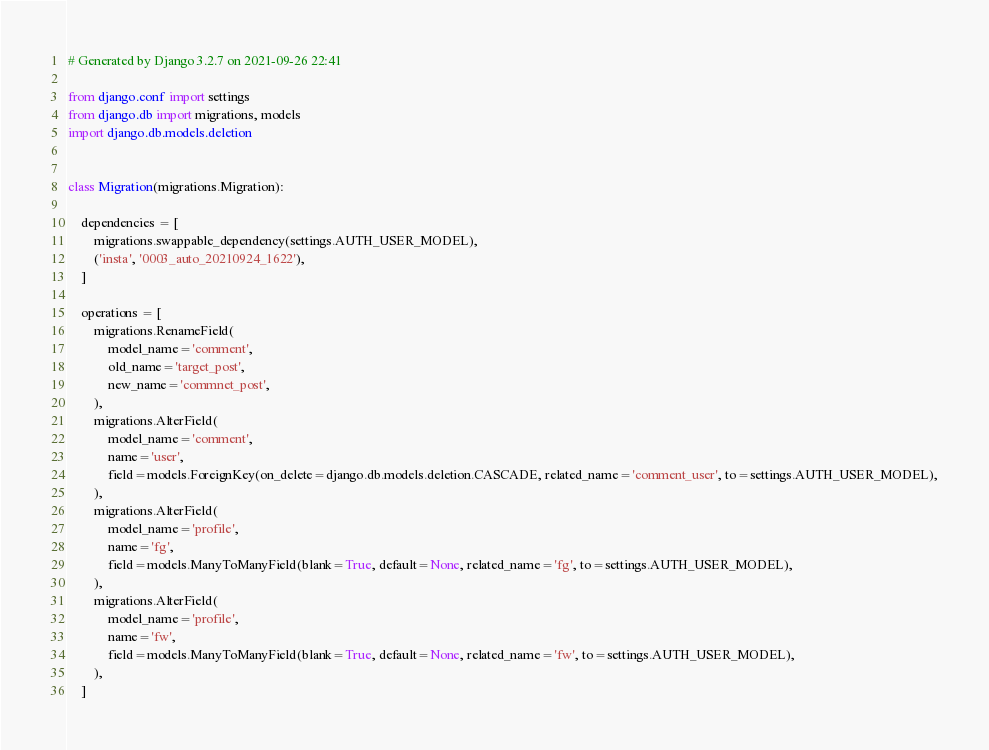Convert code to text. <code><loc_0><loc_0><loc_500><loc_500><_Python_># Generated by Django 3.2.7 on 2021-09-26 22:41

from django.conf import settings
from django.db import migrations, models
import django.db.models.deletion


class Migration(migrations.Migration):

    dependencies = [
        migrations.swappable_dependency(settings.AUTH_USER_MODEL),
        ('insta', '0003_auto_20210924_1622'),
    ]

    operations = [
        migrations.RenameField(
            model_name='comment',
            old_name='target_post',
            new_name='commnet_post',
        ),
        migrations.AlterField(
            model_name='comment',
            name='user',
            field=models.ForeignKey(on_delete=django.db.models.deletion.CASCADE, related_name='comment_user', to=settings.AUTH_USER_MODEL),
        ),
        migrations.AlterField(
            model_name='profile',
            name='fg',
            field=models.ManyToManyField(blank=True, default=None, related_name='fg', to=settings.AUTH_USER_MODEL),
        ),
        migrations.AlterField(
            model_name='profile',
            name='fw',
            field=models.ManyToManyField(blank=True, default=None, related_name='fw', to=settings.AUTH_USER_MODEL),
        ),
    ]
</code> 